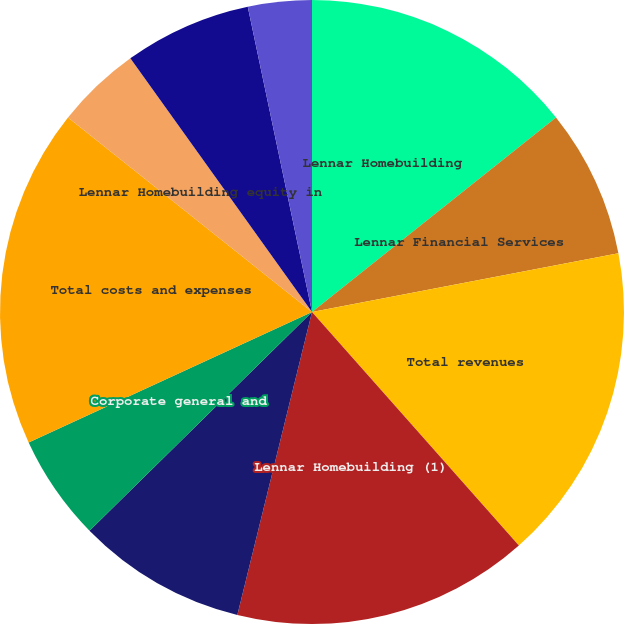Convert chart. <chart><loc_0><loc_0><loc_500><loc_500><pie_chart><fcel>Lennar Homebuilding<fcel>Lennar Financial Services<fcel>Total revenues<fcel>Lennar Homebuilding (1)<fcel>Lennar Financial Services (2)<fcel>Corporate general and<fcel>Total costs and expenses<fcel>Lennar Homebuilding equity in<fcel>Lennar Homebuilding other<fcel>Other interest expense<nl><fcel>14.29%<fcel>7.69%<fcel>16.48%<fcel>15.38%<fcel>8.79%<fcel>5.49%<fcel>17.58%<fcel>4.4%<fcel>6.59%<fcel>3.3%<nl></chart> 